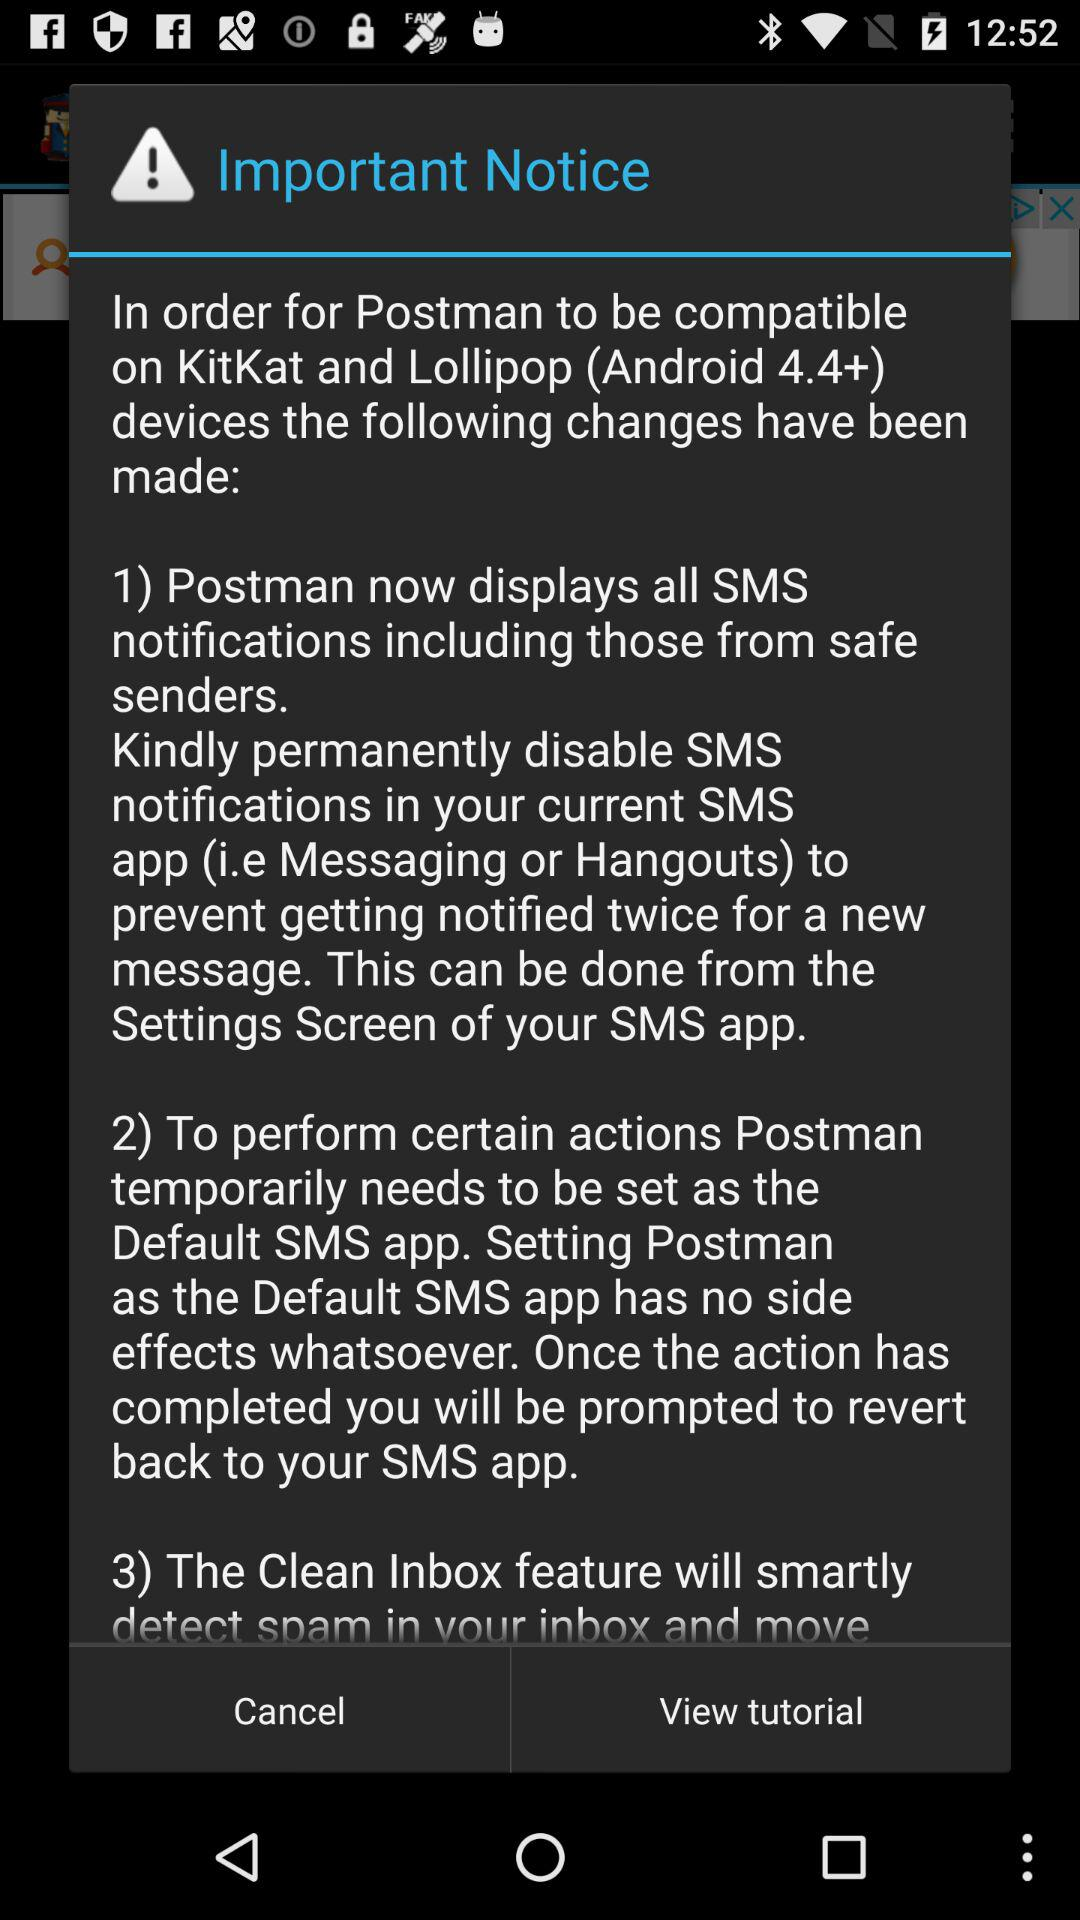How many actions are mentioned in the notice?
Answer the question using a single word or phrase. 3 